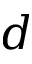<formula> <loc_0><loc_0><loc_500><loc_500>d</formula> 